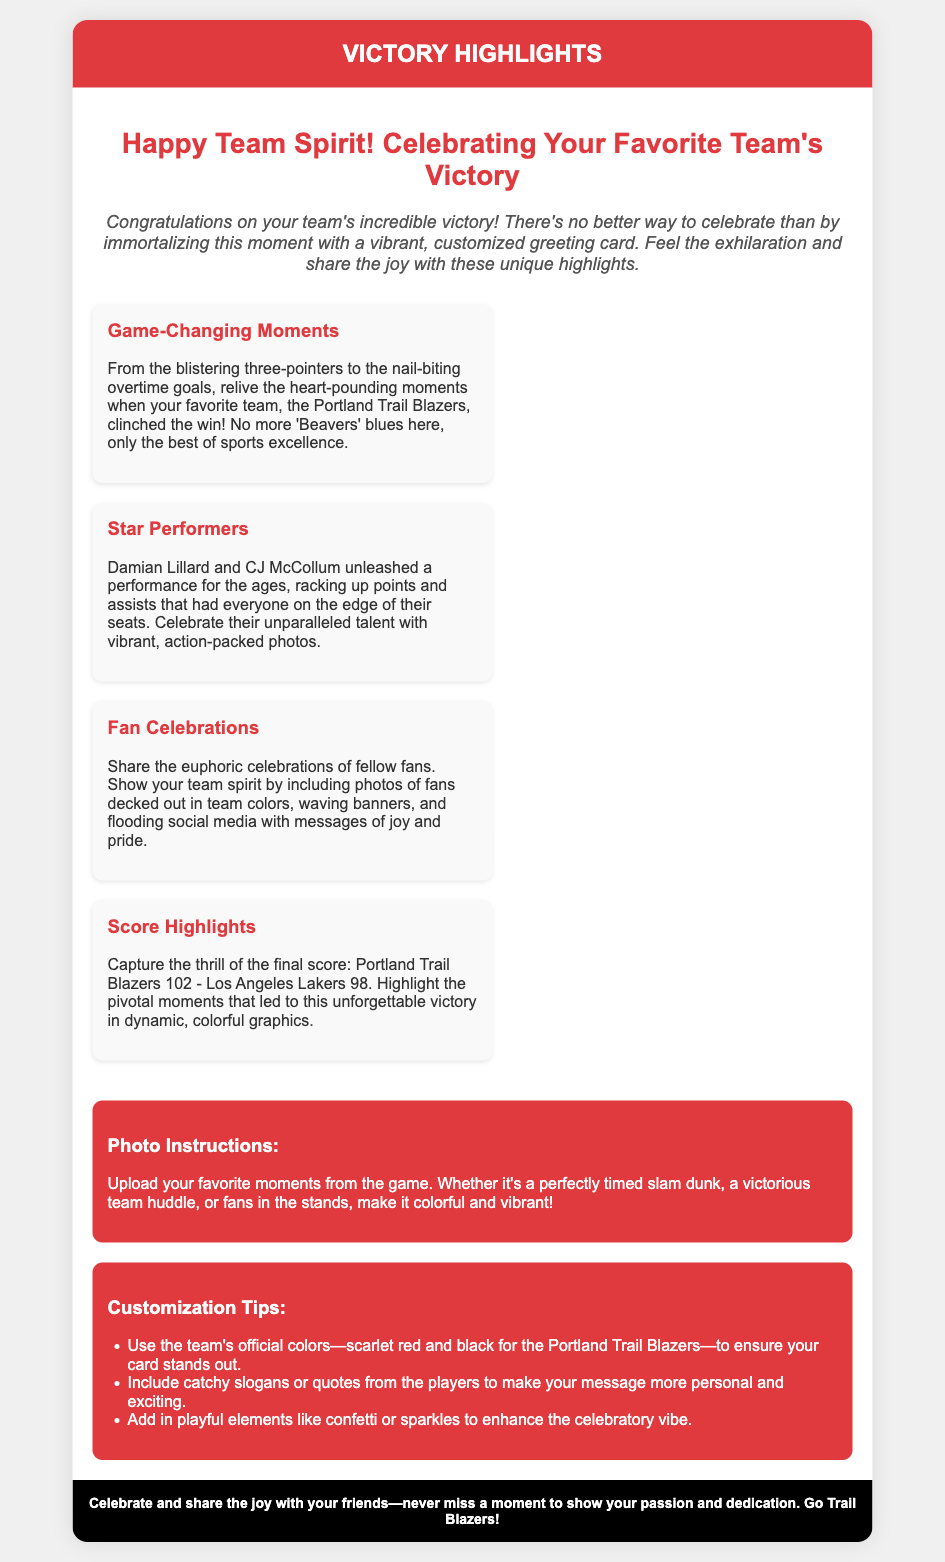What is the title of the card? The title is prominently displayed at the top of the card, celebrating the theme of team spirit and victory.
Answer: Happy Team Spirit! Celebrating Your Favorite Team's Victory Who are the star performers mentioned? The document highlights specific athletes known for their exceptional performance during the game.
Answer: Damian Lillard and CJ McCollum What are the team colors suggested for the card? The document mentions specific colors to be used for customization that align with the team's branding.
Answer: Scarlet red and black What was the final score of the game? The score is clearly stated in the highlights section of the card, representing the team's victory.
Answer: Portland Trail Blazers 102 - Los Angeles Lakers 98 What is the main theme of the card? The document emphasizes a specific celebration aspect surrounding the team's victory and fan engagement.
Answer: Team Spirit How many highlight sections are included in the document? The highlights section is broken down into distinct topics to provide detailed insights about the game.
Answer: Four What kind of photos are recommended to upload? The document provides specific suggestions for the type of images that would enhance the card's message.
Answer: Favorite moments from the game What type of document is this? The overall structure and content of the document indicate its purpose as a celebratory message associated with a sports event.
Answer: Greeting card 